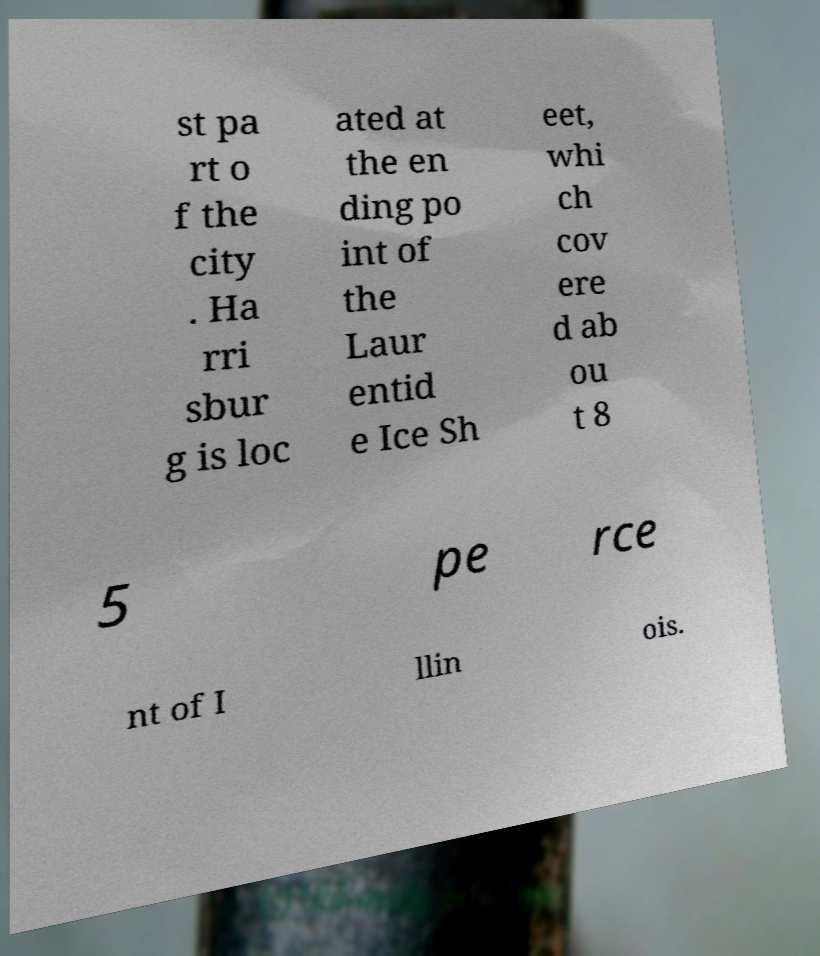Could you assist in decoding the text presented in this image and type it out clearly? st pa rt o f the city . Ha rri sbur g is loc ated at the en ding po int of the Laur entid e Ice Sh eet, whi ch cov ere d ab ou t 8 5 pe rce nt of I llin ois. 